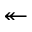Convert formula to latex. <formula><loc_0><loc_0><loc_500><loc_500>\twoheadleftarrow</formula> 